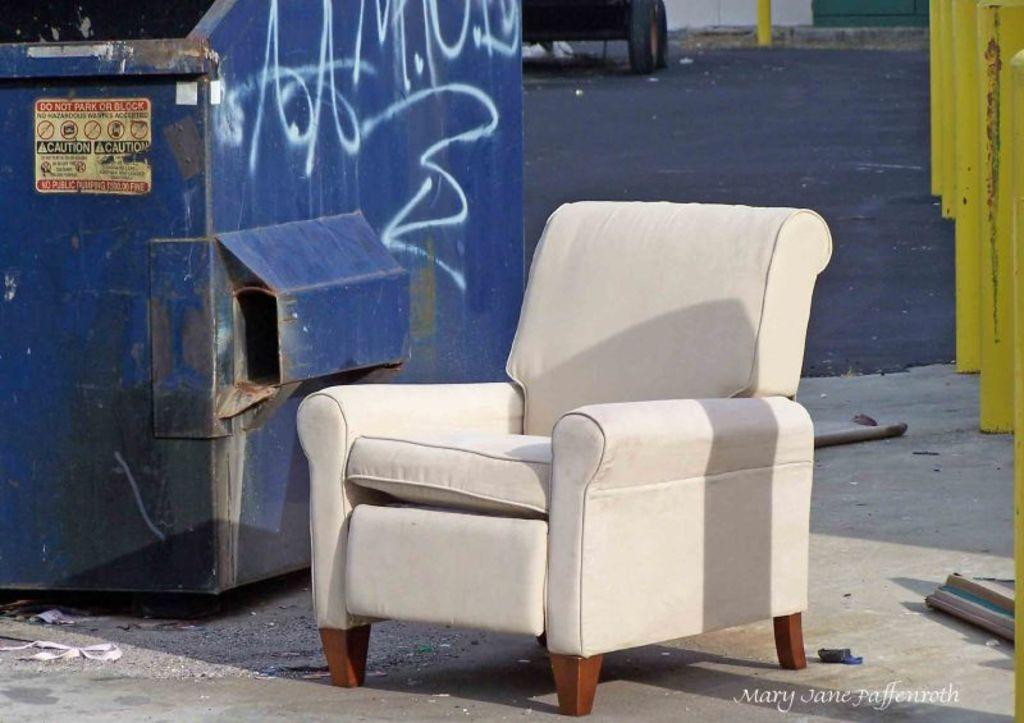What type of furniture is present in the image? There is a couch in the image. Where is the dustbin located in the image? The dustbin is on the left side of the image. What warning is indicated on the dustbin? The dustbin has a "CAUTION" label. What can be seen in the background of the image? There is a road visible in the background of the image. What is the color of the road in the image? The road appears to be black in color. What type of cake is being shared by the friends in the image? There are no friends or cake present in the image. What is the voice of the person speaking in the image? There is no person speaking in the image. 